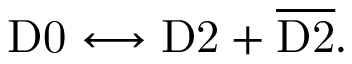<formula> <loc_0><loc_0><loc_500><loc_500>D 0 \longleftrightarrow D 2 + { \overline { D 2 } } .</formula> 